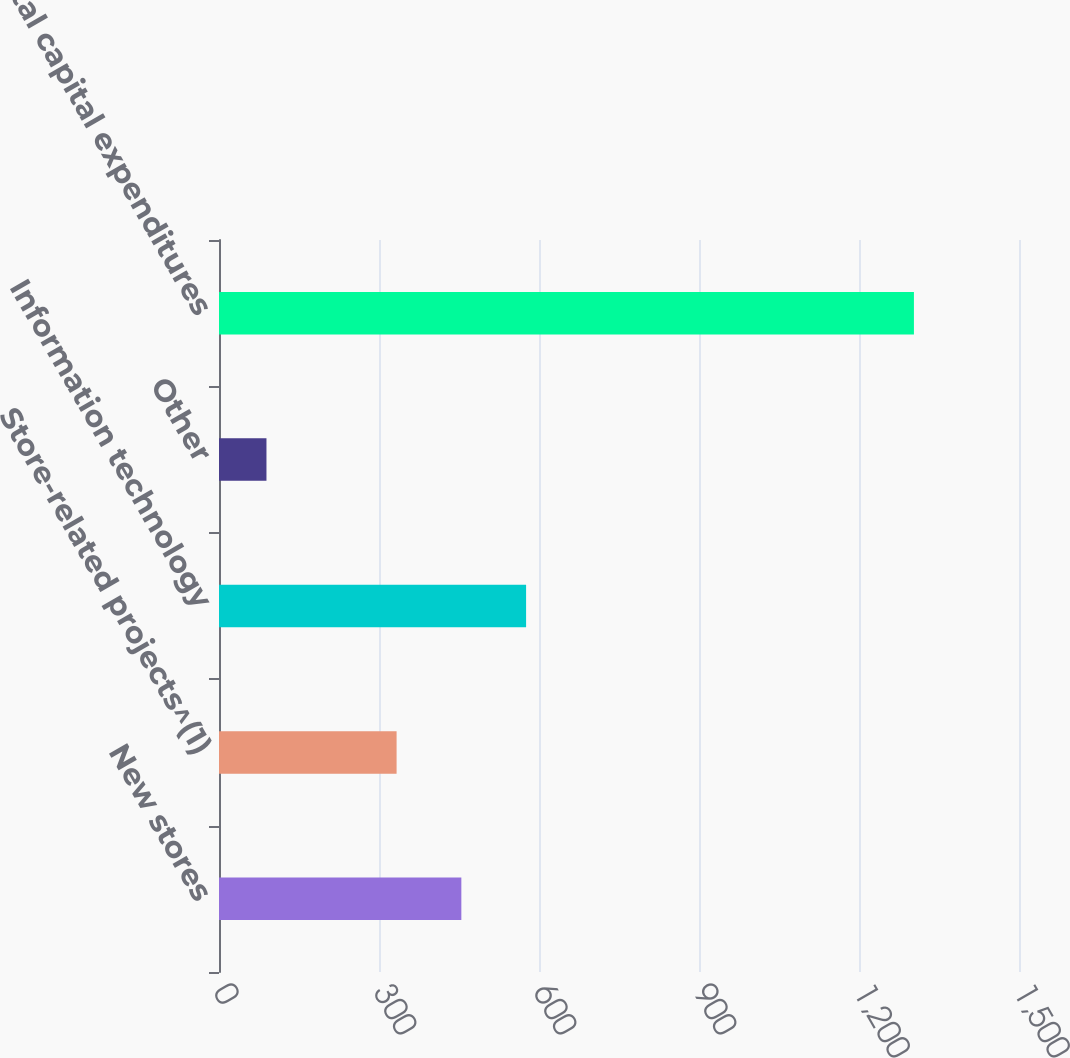Convert chart to OTSL. <chart><loc_0><loc_0><loc_500><loc_500><bar_chart><fcel>New stores<fcel>Store-related projects^(1)<fcel>Information technology<fcel>Other<fcel>Total capital expenditures<nl><fcel>454.4<fcel>333<fcel>575.8<fcel>89<fcel>1303<nl></chart> 